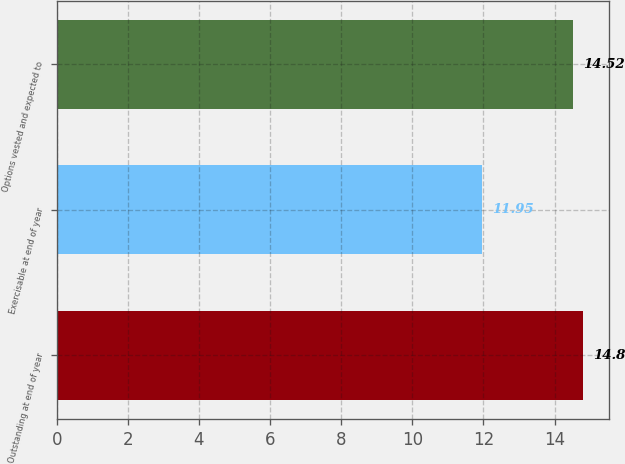<chart> <loc_0><loc_0><loc_500><loc_500><bar_chart><fcel>Outstanding at end of year<fcel>Exercisable at end of year<fcel>Options vested and expected to<nl><fcel>14.8<fcel>11.95<fcel>14.52<nl></chart> 